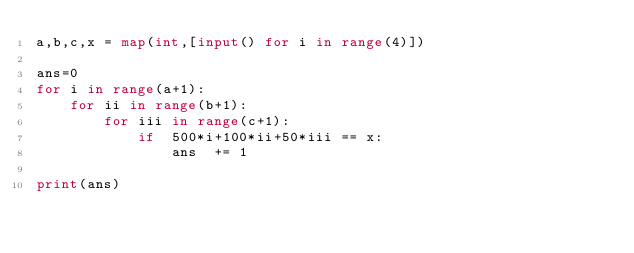Convert code to text. <code><loc_0><loc_0><loc_500><loc_500><_Python_>a,b,c,x = map(int,[input() for i in range(4)])

ans=0
for i in range(a+1):
    for ii in range(b+1):
        for iii in range(c+1):
            if  500*i+100*ii+50*iii == x:
                ans  += 1

print(ans)
</code> 